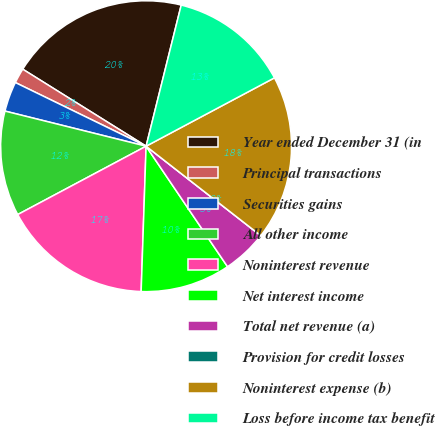Convert chart. <chart><loc_0><loc_0><loc_500><loc_500><pie_chart><fcel>Year ended December 31 (in<fcel>Principal transactions<fcel>Securities gains<fcel>All other income<fcel>Noninterest revenue<fcel>Net interest income<fcel>Total net revenue (a)<fcel>Provision for credit losses<fcel>Noninterest expense (b)<fcel>Loss before income tax benefit<nl><fcel>20.0%<fcel>1.67%<fcel>3.33%<fcel>11.67%<fcel>16.67%<fcel>10.0%<fcel>5.0%<fcel>0.0%<fcel>18.33%<fcel>13.33%<nl></chart> 